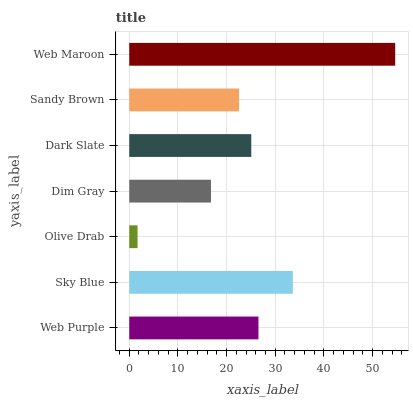Is Olive Drab the minimum?
Answer yes or no. Yes. Is Web Maroon the maximum?
Answer yes or no. Yes. Is Sky Blue the minimum?
Answer yes or no. No. Is Sky Blue the maximum?
Answer yes or no. No. Is Sky Blue greater than Web Purple?
Answer yes or no. Yes. Is Web Purple less than Sky Blue?
Answer yes or no. Yes. Is Web Purple greater than Sky Blue?
Answer yes or no. No. Is Sky Blue less than Web Purple?
Answer yes or no. No. Is Dark Slate the high median?
Answer yes or no. Yes. Is Dark Slate the low median?
Answer yes or no. Yes. Is Sandy Brown the high median?
Answer yes or no. No. Is Sky Blue the low median?
Answer yes or no. No. 